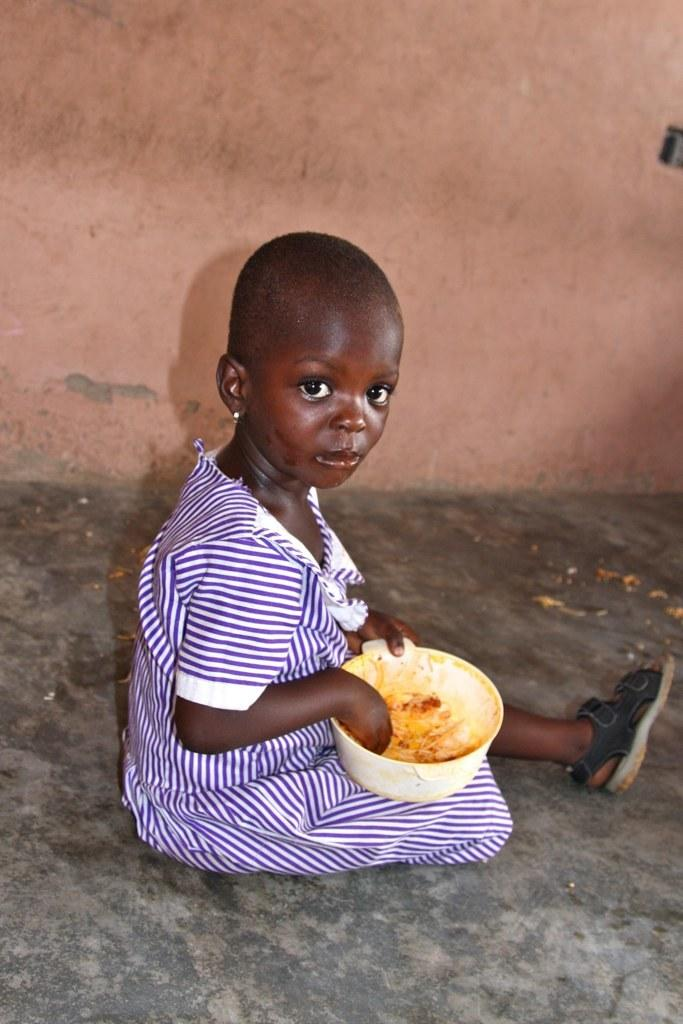Who is the main subject in the image? There is a girl in the image. What is the girl doing in the image? The girl is sitting on the floor and eating food. What can be seen behind the girl? There is a wall behind the girl. What type of spot can be seen on the girl's shirt in the image? There is no spot visible on the girl's shirt in the image. What kind of soap is the girl using to wash her hands in the image? There is no soap or hand-washing activity depicted in the image. 